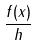Convert formula to latex. <formula><loc_0><loc_0><loc_500><loc_500>\frac { f ( x ) } { h }</formula> 